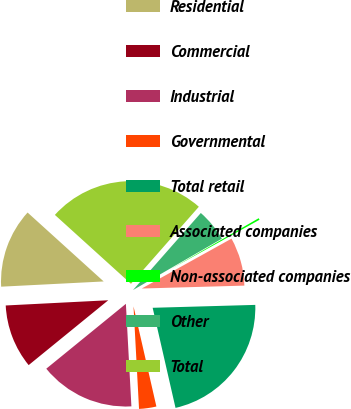<chart> <loc_0><loc_0><loc_500><loc_500><pie_chart><fcel>Residential<fcel>Commercial<fcel>Industrial<fcel>Governmental<fcel>Total retail<fcel>Associated companies<fcel>Non-associated companies<fcel>Other<fcel>Total<nl><fcel>12.52%<fcel>10.07%<fcel>14.97%<fcel>2.72%<fcel>21.87%<fcel>7.62%<fcel>0.27%<fcel>5.17%<fcel>24.77%<nl></chart> 